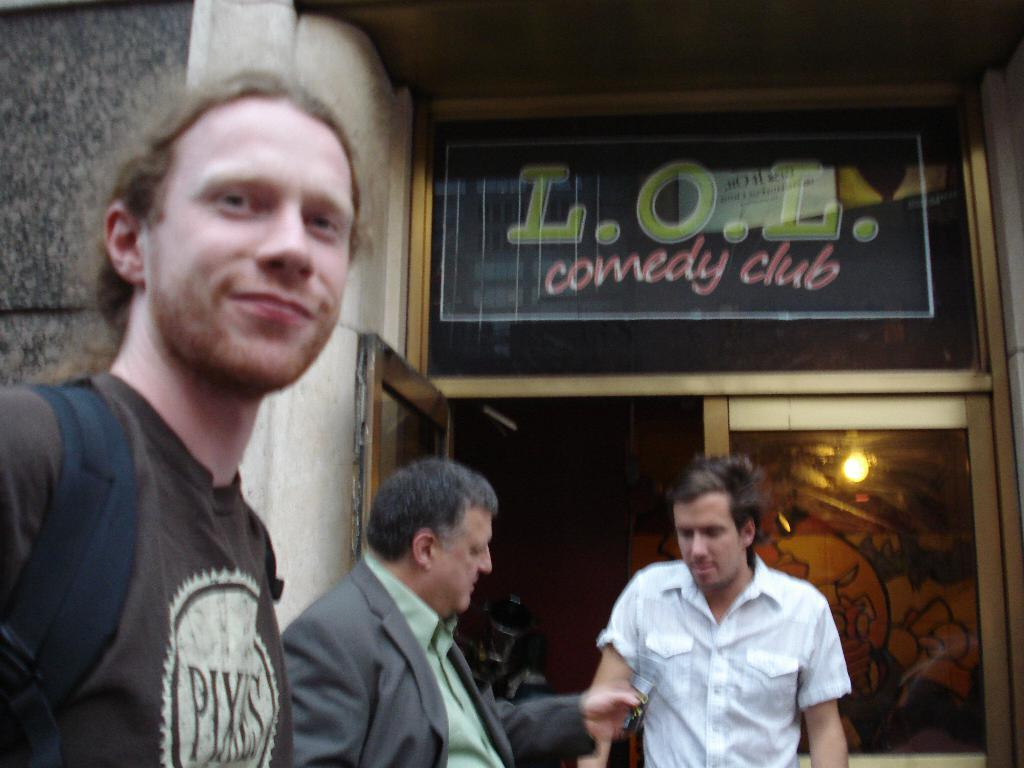What is the man on the left side of the image wearing? The man on the left side of the image is wearing a backpack. How many men are in the middle of the image? There are two men in the middle of the image. What can be seen in the background of the image? There is a glass door and a wall in the background of the image. What type of meat is the man on the right side of the image holding? There is no man on the right side of the image, and no meat is visible in the image. 